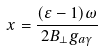Convert formula to latex. <formula><loc_0><loc_0><loc_500><loc_500>x = \frac { ( \varepsilon - 1 ) \omega } { 2 B _ { \bot } g _ { a \gamma } }</formula> 